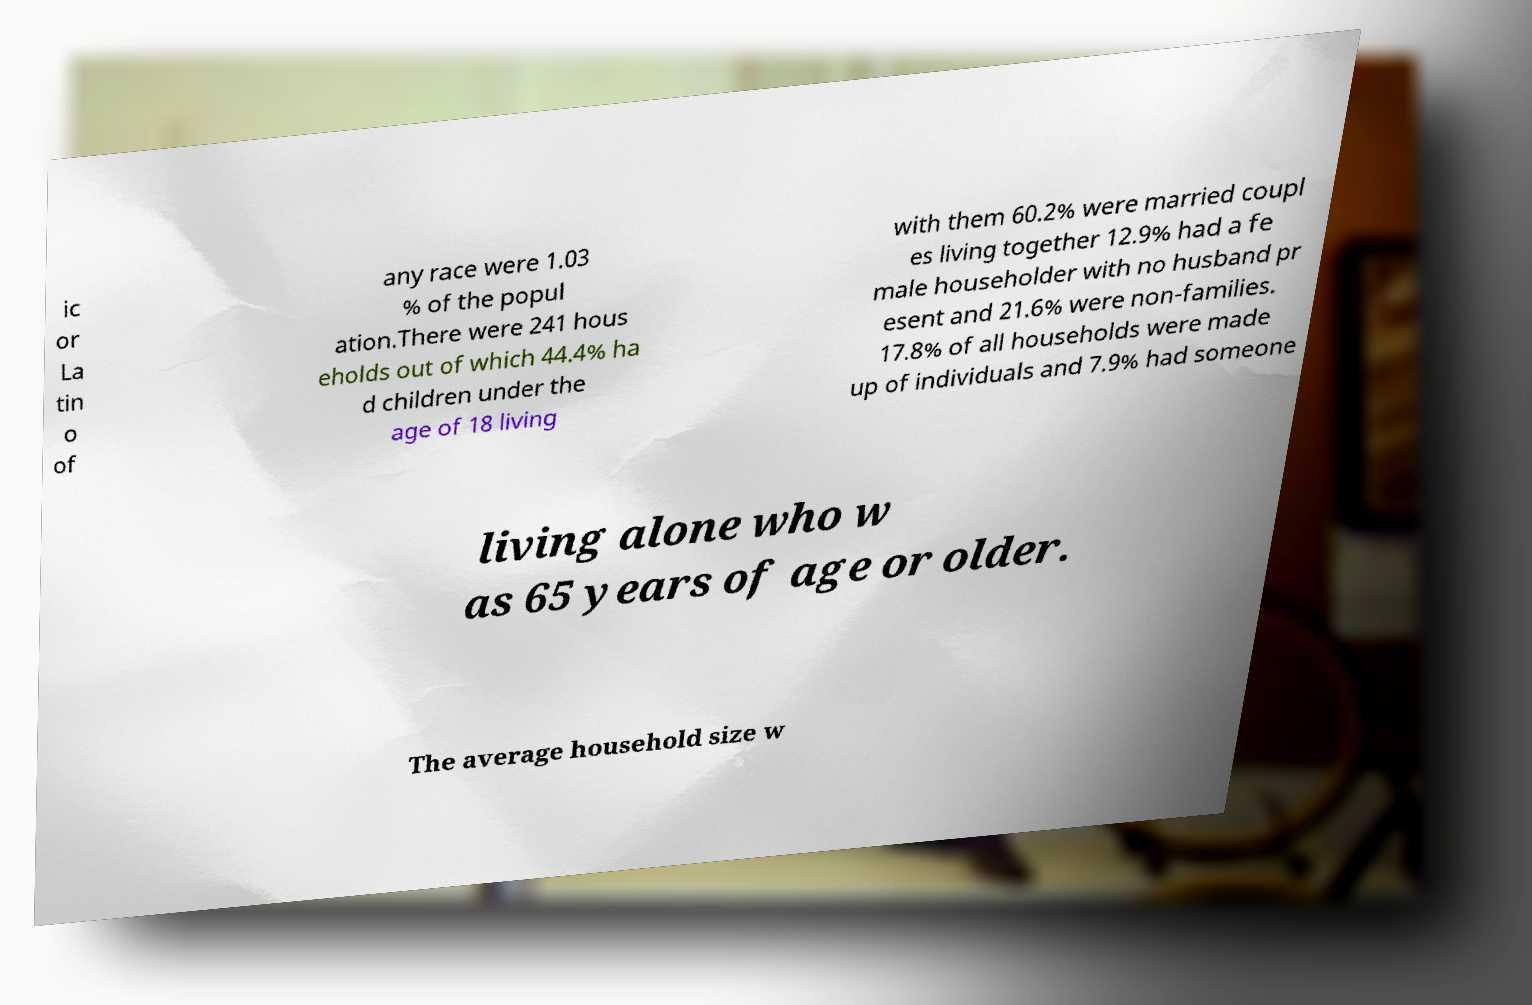I need the written content from this picture converted into text. Can you do that? ic or La tin o of any race were 1.03 % of the popul ation.There were 241 hous eholds out of which 44.4% ha d children under the age of 18 living with them 60.2% were married coupl es living together 12.9% had a fe male householder with no husband pr esent and 21.6% were non-families. 17.8% of all households were made up of individuals and 7.9% had someone living alone who w as 65 years of age or older. The average household size w 